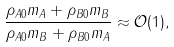<formula> <loc_0><loc_0><loc_500><loc_500>\frac { \rho _ { A 0 } m _ { A } + \rho _ { B 0 } m _ { B } } { \rho _ { A 0 } m _ { B } + \rho _ { B 0 } m _ { A } } \approx \mathcal { O } ( 1 ) ,</formula> 